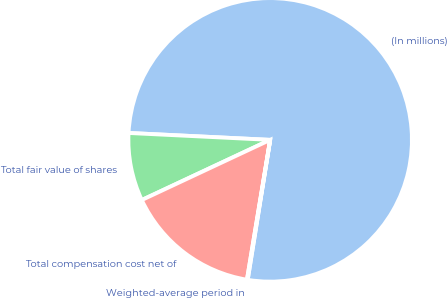Convert chart. <chart><loc_0><loc_0><loc_500><loc_500><pie_chart><fcel>(In millions)<fcel>Total fair value of shares<fcel>Total compensation cost net of<fcel>Weighted-average period in<nl><fcel>76.76%<fcel>7.75%<fcel>15.41%<fcel>0.08%<nl></chart> 